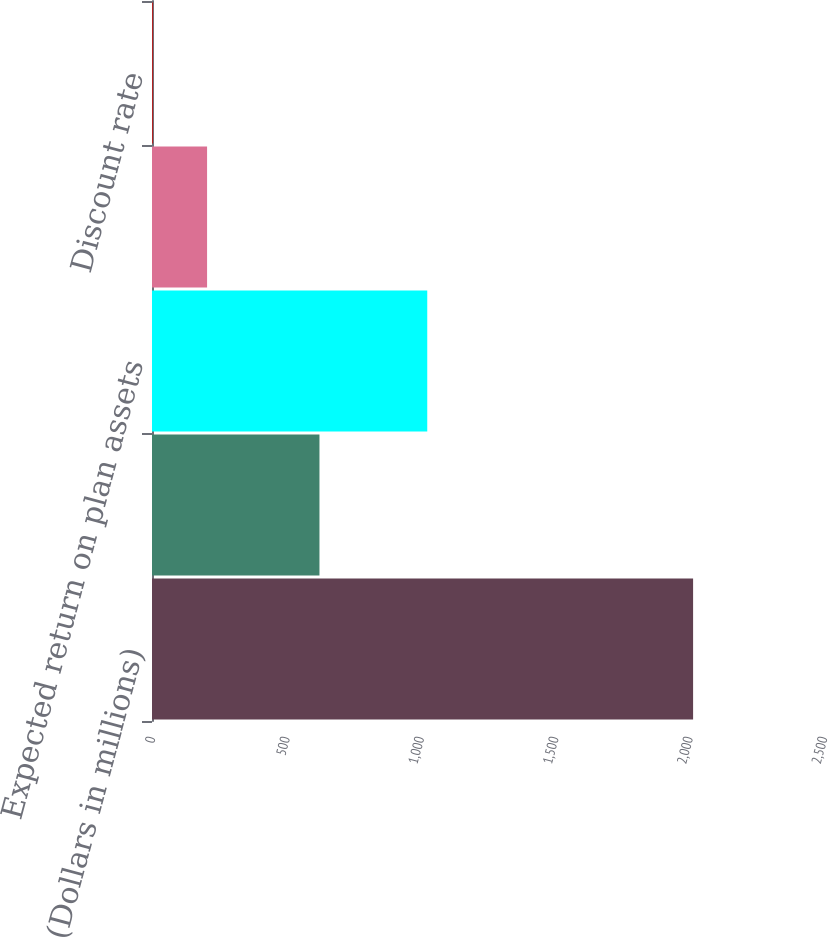Convert chart to OTSL. <chart><loc_0><loc_0><loc_500><loc_500><bar_chart><fcel>(Dollars in millions)<fcel>Interest cost<fcel>Expected return on plan assets<fcel>Net periodic benefit cost<fcel>Discount rate<nl><fcel>2013<fcel>623<fcel>1024<fcel>204.9<fcel>4<nl></chart> 